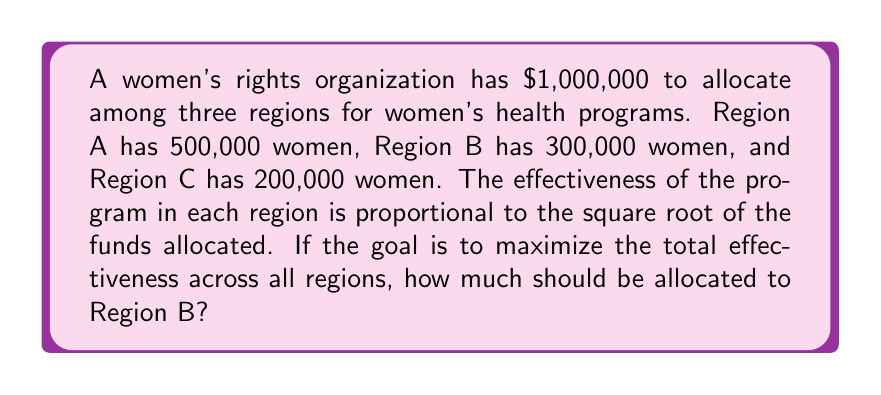Solve this math problem. Let's approach this step-by-step:

1) Let $x$, $y$, and $z$ be the funds allocated to Regions A, B, and C respectively.

2) The effectiveness in each region is proportional to the square root of funds allocated, so we can express it as:
   Region A: $k\sqrt{x}\cdot500000$
   Region B: $k\sqrt{y}\cdot300000$
   Region C: $k\sqrt{z}\cdot200000$
   where $k$ is some constant.

3) Our objective is to maximize:
   $$f(x,y,z) = 500000\sqrt{x} + 300000\sqrt{y} + 200000\sqrt{z}$$

4) Subject to the constraint:
   $$x + y + z = 1000000$$

5) Using the method of Lagrange multipliers, we set up:
   $$\frac{\partial f}{\partial x} = \frac{\partial f}{\partial y} = \frac{\partial f}{\partial z}$$

6) This gives us:
   $$\frac{250000}{\sqrt{x}} = \frac{150000}{\sqrt{y}} = \frac{100000}{\sqrt{z}}$$

7) From this, we can deduce:
   $$\frac{x}{(250000)^2} = \frac{y}{(150000)^2} = \frac{z}{(100000)^2}$$

8) Let's call this common ratio $r$. Then:
   $x = r(250000)^2$
   $y = r(150000)^2$
   $z = r(100000)^2$

9) Substituting into our constraint equation:
   $r(250000)^2 + r(150000)^2 + r(100000)^2 = 1000000$

10) Solving for $r$:
    $r = \frac{1000000}{(250000)^2 + (150000)^2 + (100000)^2} = \frac{4}{37}$

11) Therefore, the allocation for Region B is:
    $y = \frac{4}{37} \cdot (150000)^2 = 243243.24$
Answer: $243,243.24 